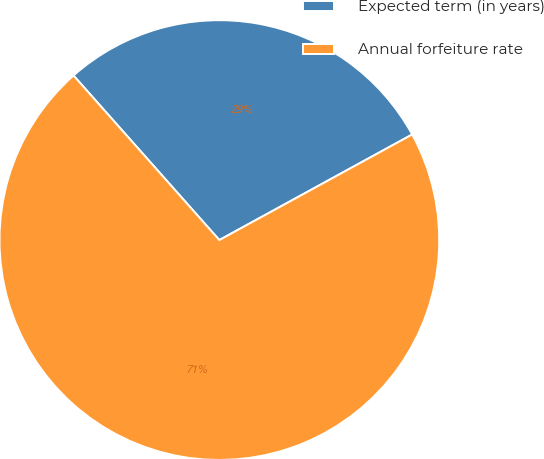<chart> <loc_0><loc_0><loc_500><loc_500><pie_chart><fcel>Expected term (in years)<fcel>Annual forfeiture rate<nl><fcel>28.57%<fcel>71.43%<nl></chart> 